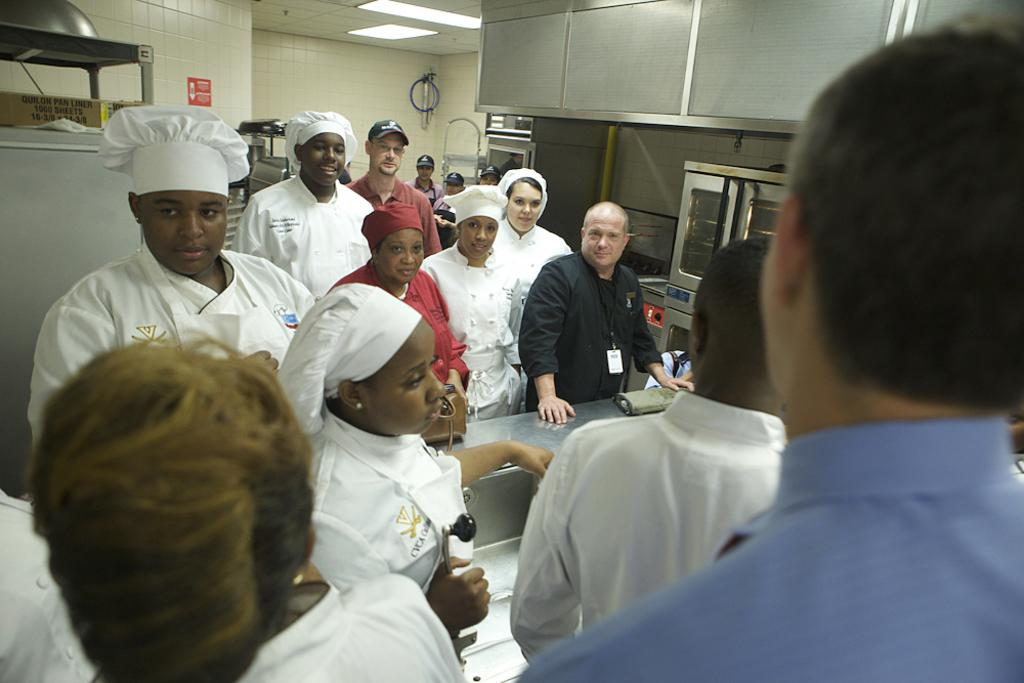How many people are in the group visible in the image? There is a group of people standing in the image, but the exact number cannot be determined from the provided facts. What type of structure can be seen in the image? There are walls visible in the image, which suggests that the group of people is inside a building or room. What is hanging from the ceiling in the image? There is a ceiling with lights in the image, but the specific type of lights cannot be determined from the provided facts. What type of furniture is present in the image? There is a cabinet in the image, which is a type of furniture used for storage. Can you describe any other objects present in the image? There are other objects present in the image, but their specific nature cannot be determined from the provided facts. What type of silverware is being used for lunch in the image? There is no mention of lunch or silverware in the provided facts, so we cannot answer this question. 